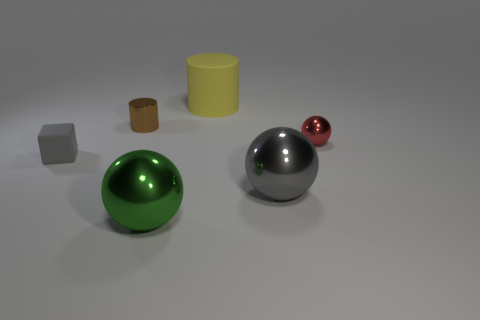Add 2 tiny red cylinders. How many objects exist? 8 Subtract all green balls. How many balls are left? 2 Subtract all yellow cylinders. How many cylinders are left? 1 Subtract 2 cylinders. How many cylinders are left? 0 Subtract all blocks. How many objects are left? 5 Add 1 tiny red objects. How many tiny red objects are left? 2 Add 5 cubes. How many cubes exist? 6 Subtract 0 purple blocks. How many objects are left? 6 Subtract all purple cubes. Subtract all brown cylinders. How many cubes are left? 1 Subtract all cyan cylinders. How many green spheres are left? 1 